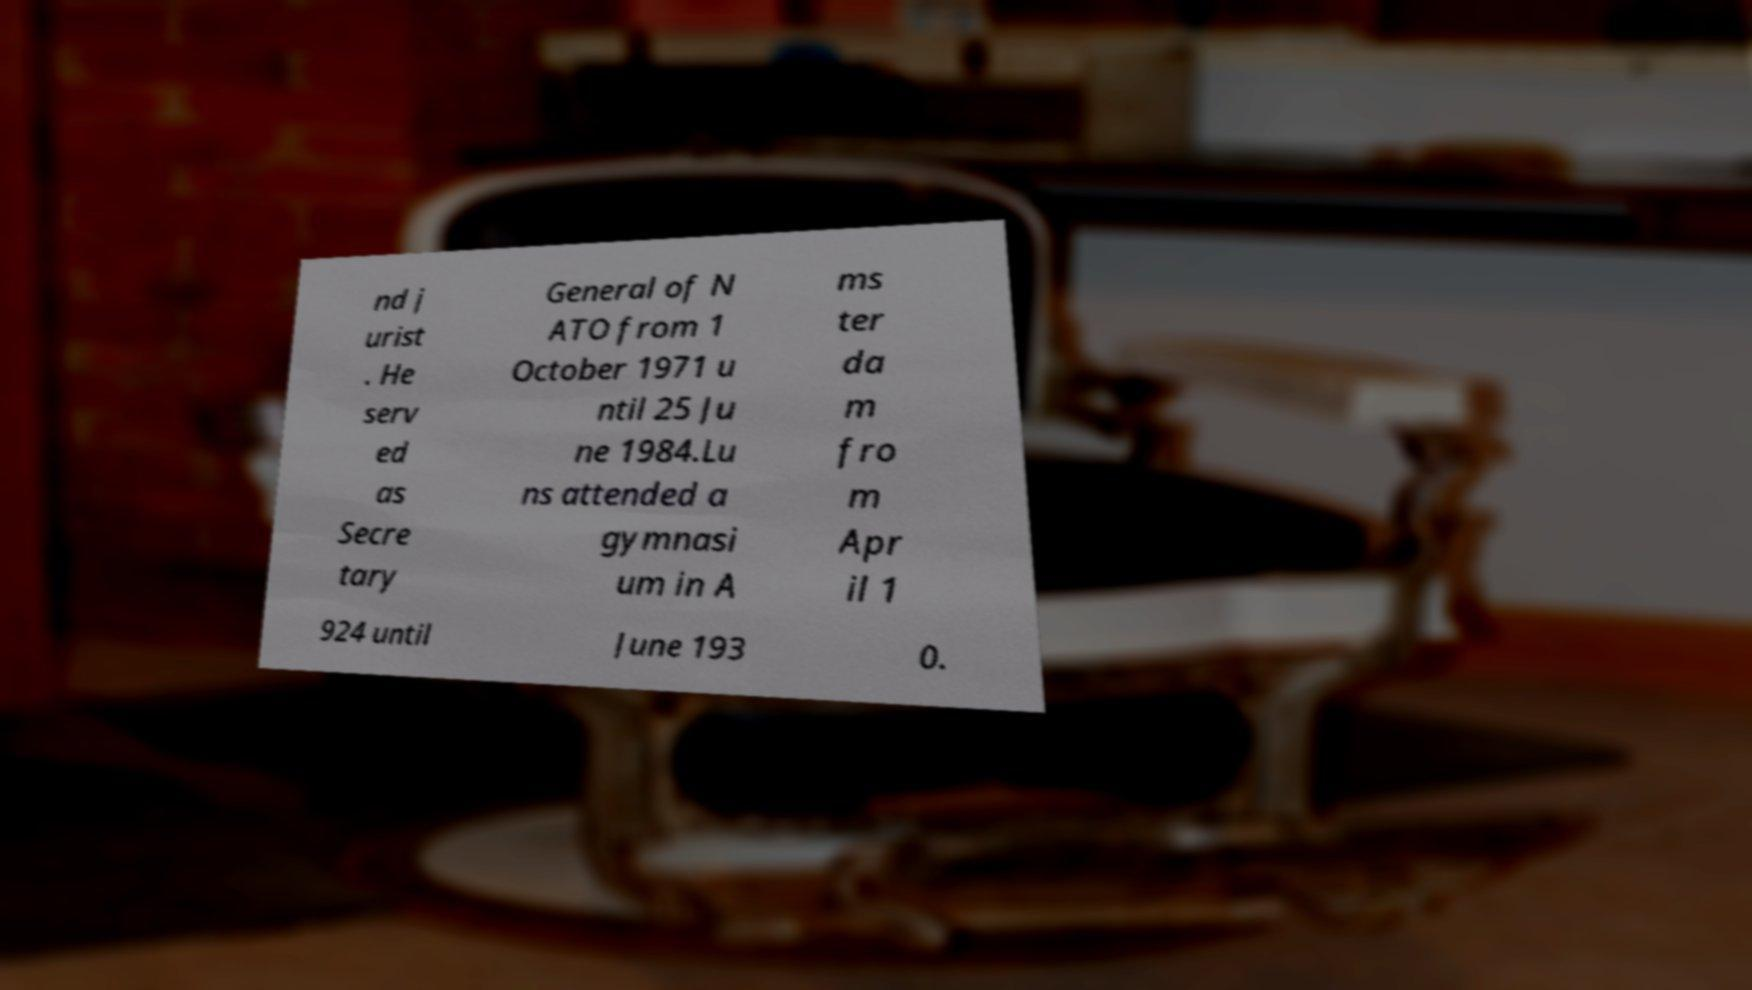Can you accurately transcribe the text from the provided image for me? nd j urist . He serv ed as Secre tary General of N ATO from 1 October 1971 u ntil 25 Ju ne 1984.Lu ns attended a gymnasi um in A ms ter da m fro m Apr il 1 924 until June 193 0. 